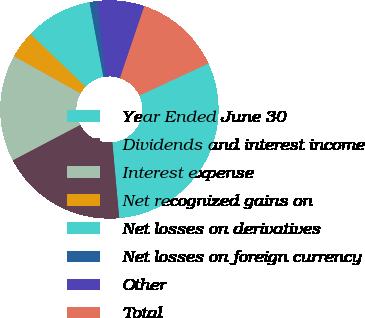Convert chart to OTSL. <chart><loc_0><loc_0><loc_500><loc_500><pie_chart><fcel>Year Ended June 30<fcel>Dividends and interest income<fcel>Interest expense<fcel>Net recognized gains on<fcel>Net losses on derivatives<fcel>Net losses on foreign currency<fcel>Other<fcel>Total<nl><fcel>30.49%<fcel>18.74%<fcel>15.8%<fcel>4.06%<fcel>9.93%<fcel>1.12%<fcel>6.99%<fcel>12.87%<nl></chart> 